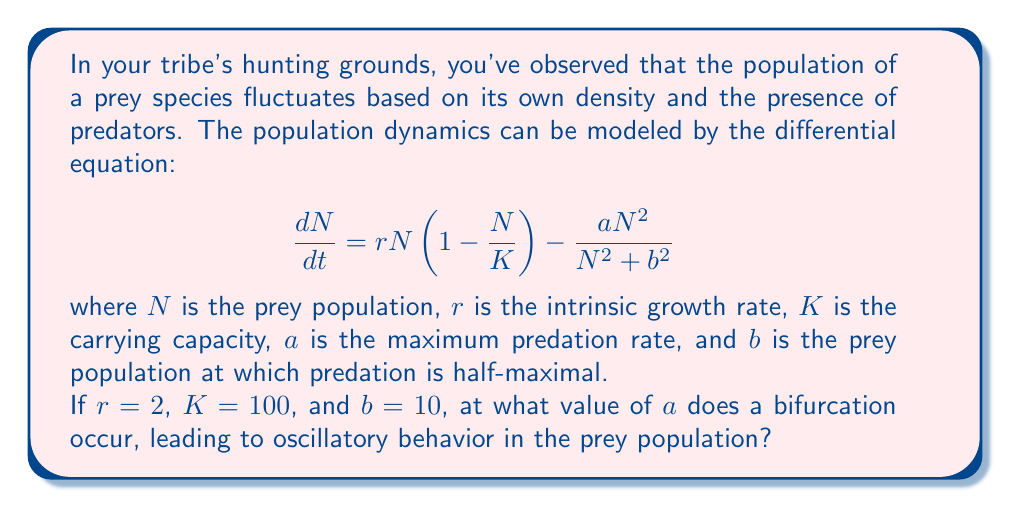Provide a solution to this math problem. To find the bifurcation point, we need to analyze the stability of the equilibrium points of the system. The steps are as follows:

1) First, find the equilibrium points by setting $\frac{dN}{dt} = 0$:

   $$0 = rN(1-\frac{N}{K}) - \frac{aN^2}{N^2 + b^2}$$

2) Substitute the given values: $r=2$, $K=100$, $b=10$:

   $$0 = 2N(1-\frac{N}{100}) - \frac{aN^2}{N^2 + 100}$$

3) Multiply both sides by $(N^2 + 100)$:

   $$0 = 2N(1-\frac{N}{100})(N^2 + 100) - aN^2$$

4) Expand:

   $$0 = 2N^3 + 200N - \frac{2N^4}{100} - 2N^2 - aN^2$$

5) Simplify:

   $$0 = 2N^3 + 200N - 0.02N^4 - (2+a)N^2$$

6) The bifurcation occurs when the real part of the eigenvalues of the Jacobian matrix changes sign. This happens when the discriminant of the characteristic equation is zero.

7) The Jacobian at equilibrium is:

   $$J = \frac{d}{dN}(\frac{dN}{dt}) = r(1-\frac{2N}{K}) - \frac{2aN^3}{(N^2+b^2)^2}$$

8) At the non-trivial equilibrium point, this should be zero for the bifurcation:

   $$2(1-\frac{2N}{100}) - \frac{2aN^3}{(N^2+100)^2} = 0$$

9) Solving this equation simultaneously with the equilibrium condition gives the bifurcation point. Due to the complexity, this is typically done numerically.

10) Using numerical methods, we find that the bifurcation occurs when $a \approx 1.08$ and $N \approx 63.8$.

At this point, the system transitions from a stable equilibrium to oscillatory behavior.
Answer: $a \approx 1.08$ 